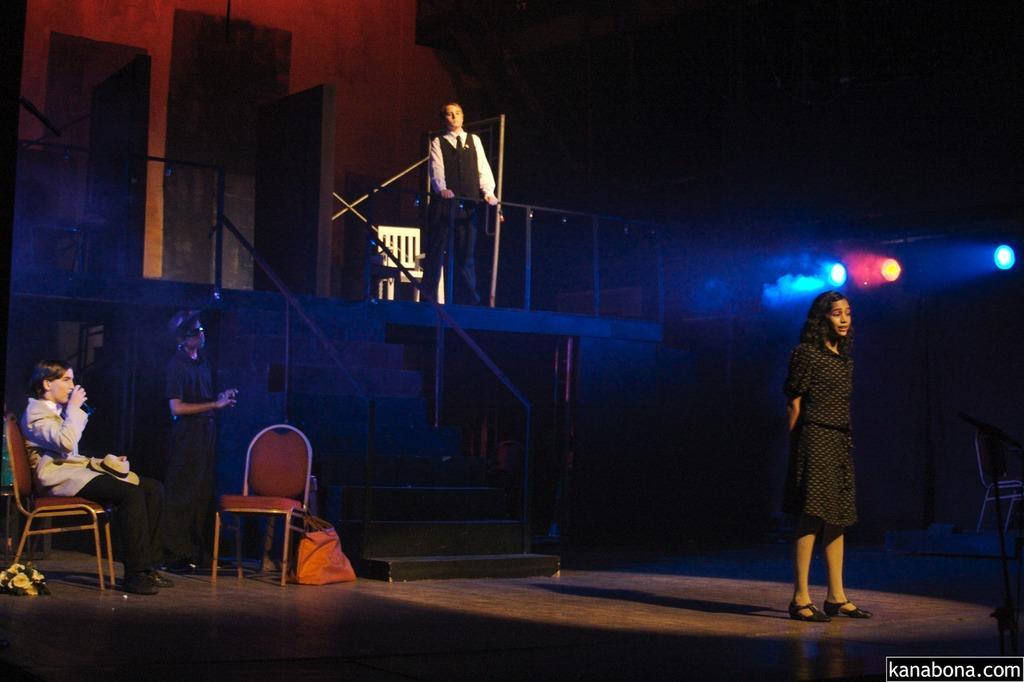How would you summarize this image in a sentence or two? In this image I can see four people where one is sitting on a chair and rest all are standing. Here I can see hat and a carry bag. I can also see few lights and few more chairs. 